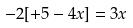Convert formula to latex. <formula><loc_0><loc_0><loc_500><loc_500>- 2 [ + 5 - 4 x ] = 3 x</formula> 